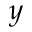<formula> <loc_0><loc_0><loc_500><loc_500>y</formula> 